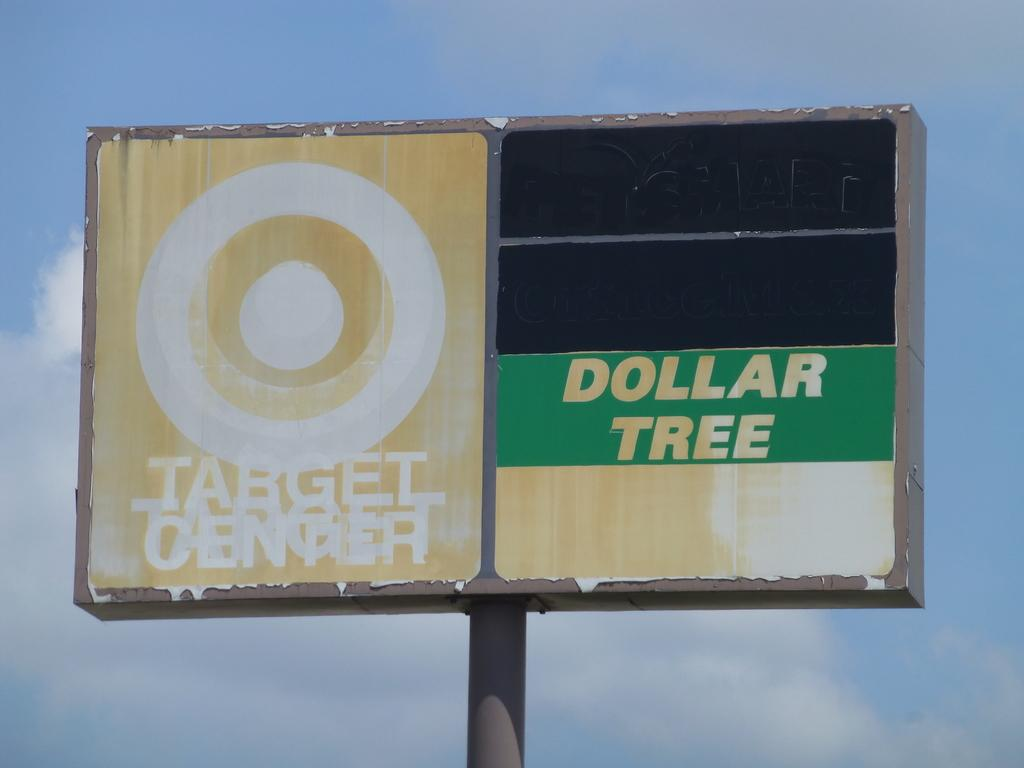<image>
Give a short and clear explanation of the subsequent image. A very old sign that has since faded of an old Dollar Tree and Target store 